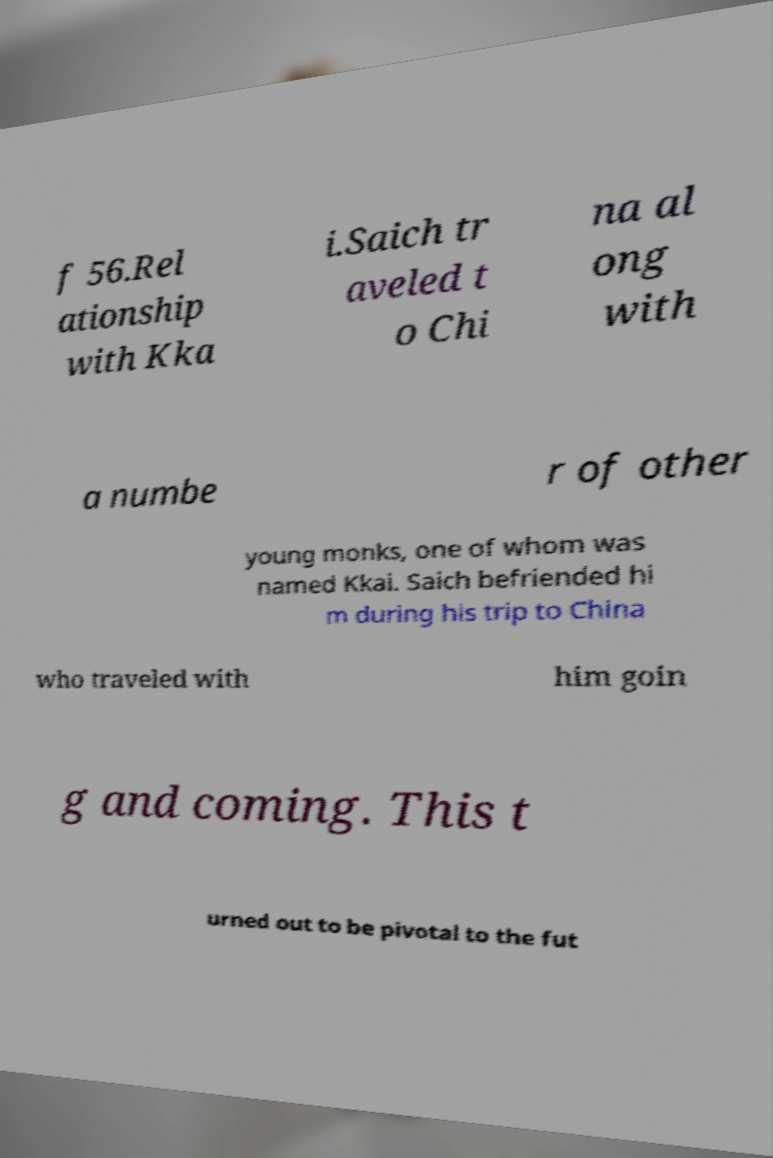What messages or text are displayed in this image? I need them in a readable, typed format. f 56.Rel ationship with Kka i.Saich tr aveled t o Chi na al ong with a numbe r of other young monks, one of whom was named Kkai. Saich befriended hi m during his trip to China who traveled with him goin g and coming. This t urned out to be pivotal to the fut 